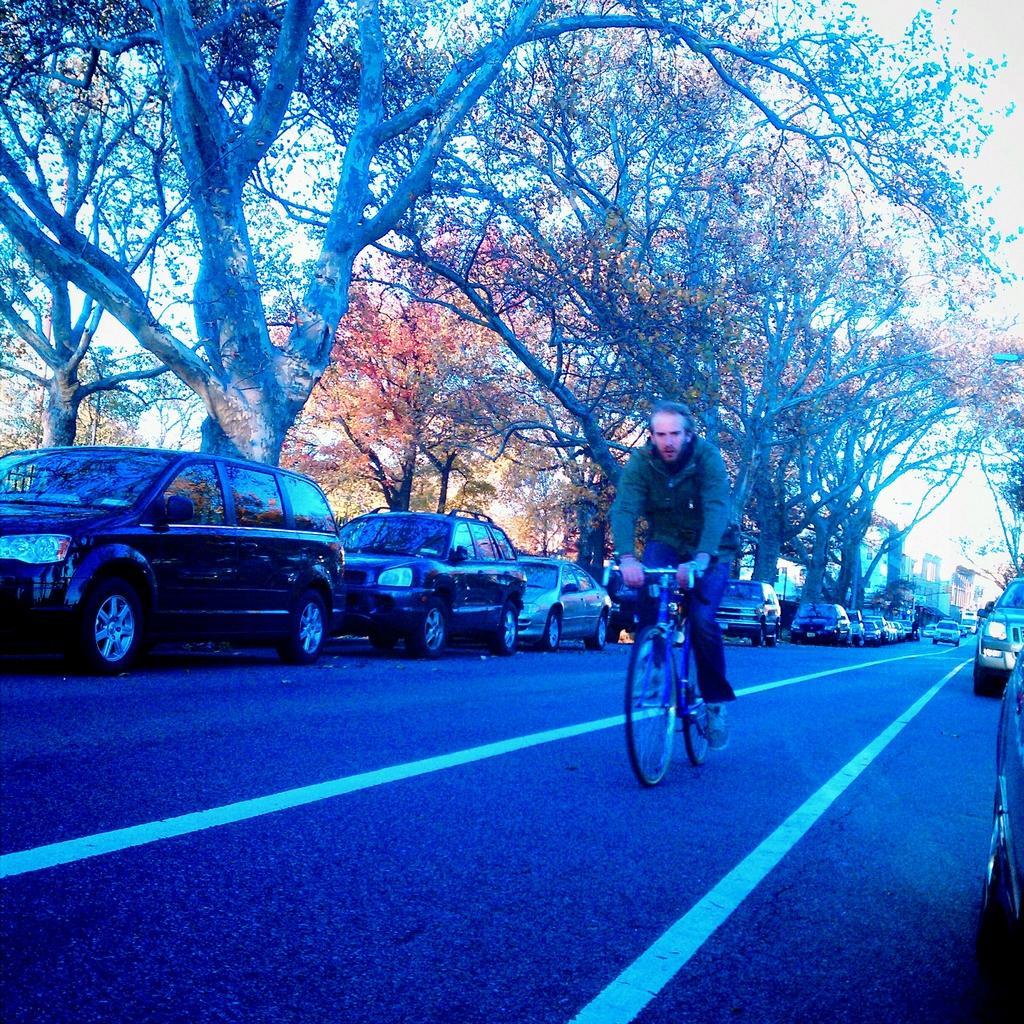How would you summarize this image in a sentence or two? This picture is clicked outside. In the center we can see a man riding a bicycle on the road and we can see the group of cars parked on the road. In the background we can see the sky, trees, buildings and some other objects. 